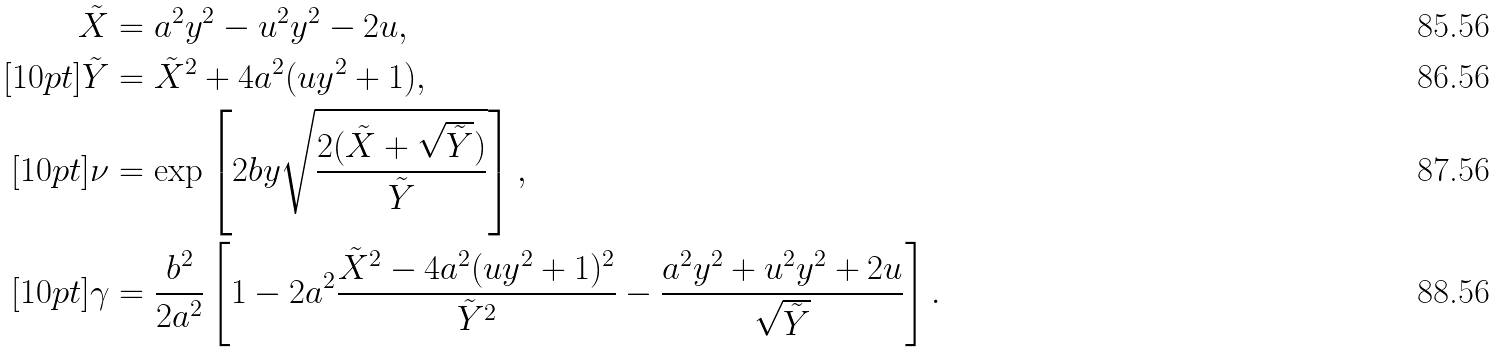<formula> <loc_0><loc_0><loc_500><loc_500>\tilde { X } & = a ^ { 2 } y ^ { 2 } - u ^ { 2 } y ^ { 2 } - 2 u , \\ [ 1 0 p t ] \tilde { Y } & = \tilde { X } ^ { 2 } + 4 a ^ { 2 } ( u y ^ { 2 } + 1 ) , \\ [ 1 0 p t ] \nu & = \exp \left [ 2 b y \sqrt { \frac { 2 ( \tilde { X } + \sqrt { \tilde { Y } } ) } { \tilde { Y } } } \right ] , \\ [ 1 0 p t ] \gamma & = \frac { b ^ { 2 } } { 2 a ^ { 2 } } \left [ 1 - 2 a ^ { 2 } \frac { \tilde { X } ^ { 2 } - 4 a ^ { 2 } ( u y ^ { 2 } + 1 ) ^ { 2 } } { \tilde { Y } ^ { 2 } } - \frac { a ^ { 2 } y ^ { 2 } + u ^ { 2 } y ^ { 2 } + 2 u } { \sqrt { \tilde { Y } } } \right ] .</formula> 